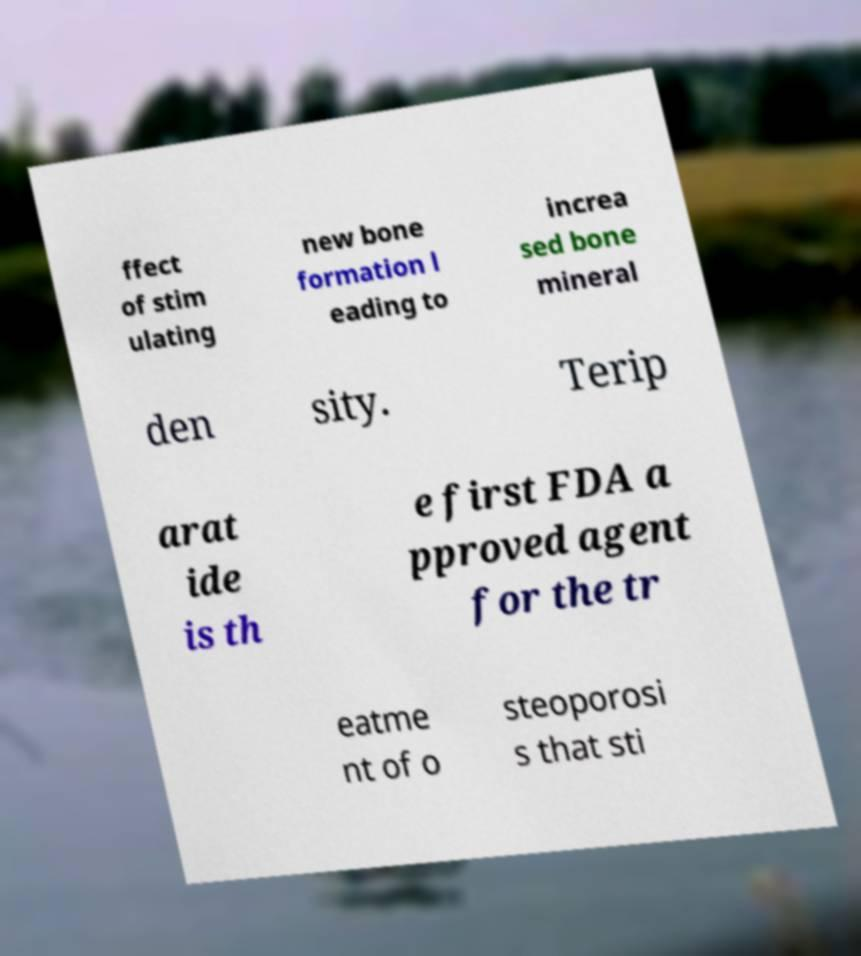For documentation purposes, I need the text within this image transcribed. Could you provide that? ffect of stim ulating new bone formation l eading to increa sed bone mineral den sity. Terip arat ide is th e first FDA a pproved agent for the tr eatme nt of o steoporosi s that sti 